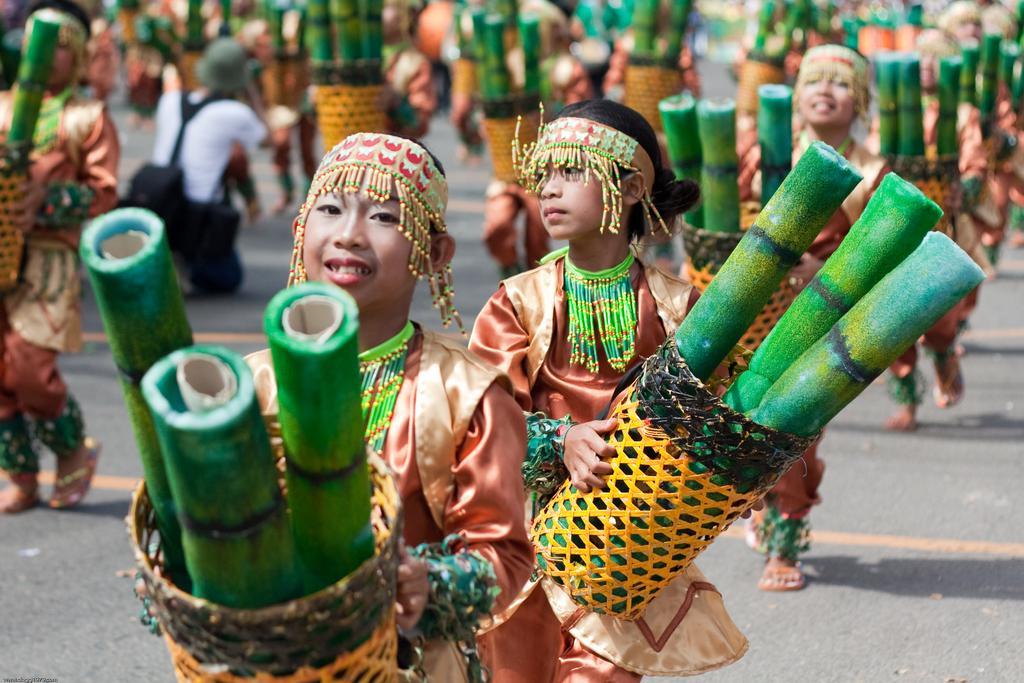In one or two sentences, can you explain what this image depicts? In this picture we can see group of people, few people holding baskets in their hands and we can see few objects in the baskets. 